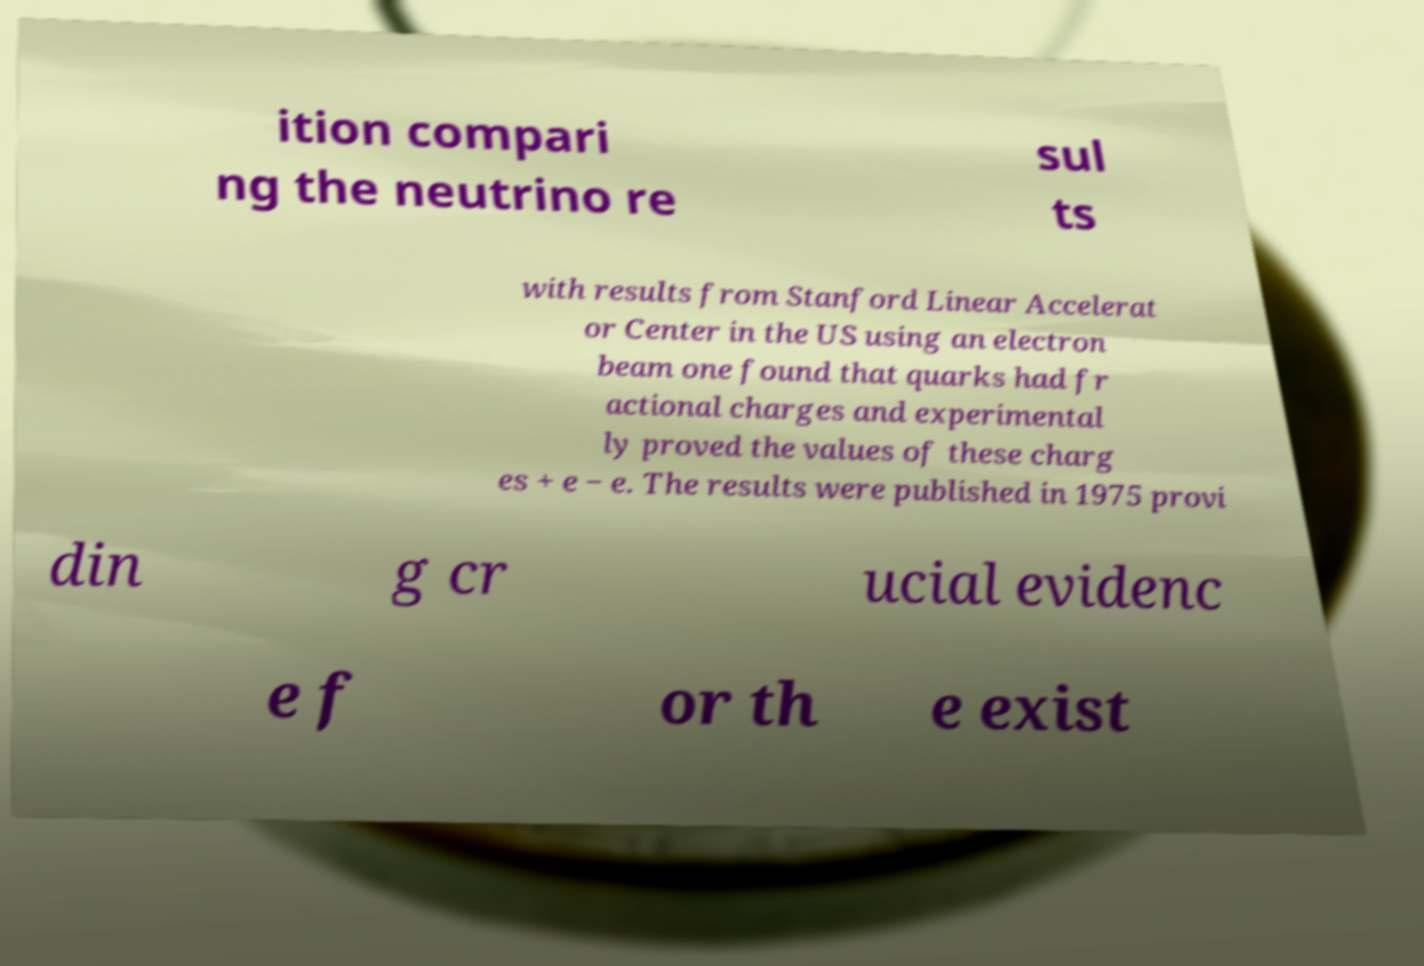There's text embedded in this image that I need extracted. Can you transcribe it verbatim? ition compari ng the neutrino re sul ts with results from Stanford Linear Accelerat or Center in the US using an electron beam one found that quarks had fr actional charges and experimental ly proved the values of these charg es + e − e. The results were published in 1975 provi din g cr ucial evidenc e f or th e exist 